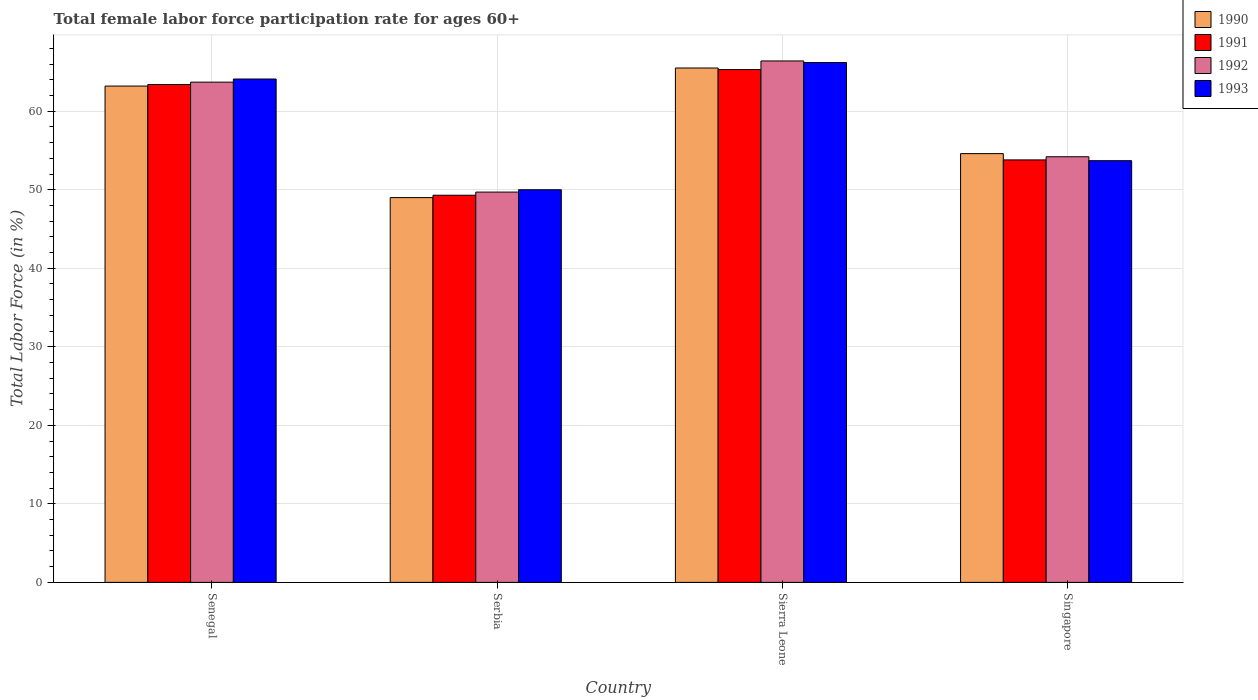How many different coloured bars are there?
Your response must be concise. 4. How many groups of bars are there?
Keep it short and to the point. 4. How many bars are there on the 4th tick from the left?
Ensure brevity in your answer.  4. How many bars are there on the 1st tick from the right?
Give a very brief answer. 4. What is the label of the 2nd group of bars from the left?
Keep it short and to the point. Serbia. What is the female labor force participation rate in 1993 in Singapore?
Offer a terse response. 53.7. Across all countries, what is the maximum female labor force participation rate in 1993?
Ensure brevity in your answer.  66.2. Across all countries, what is the minimum female labor force participation rate in 1992?
Make the answer very short. 49.7. In which country was the female labor force participation rate in 1992 maximum?
Provide a short and direct response. Sierra Leone. In which country was the female labor force participation rate in 1991 minimum?
Your answer should be very brief. Serbia. What is the total female labor force participation rate in 1993 in the graph?
Your answer should be very brief. 234. What is the difference between the female labor force participation rate in 1990 in Senegal and that in Singapore?
Offer a very short reply. 8.6. What is the difference between the female labor force participation rate in 1990 in Singapore and the female labor force participation rate in 1992 in Sierra Leone?
Offer a terse response. -11.8. What is the average female labor force participation rate in 1990 per country?
Keep it short and to the point. 58.07. What is the difference between the female labor force participation rate of/in 1992 and female labor force participation rate of/in 1993 in Serbia?
Offer a terse response. -0.3. In how many countries, is the female labor force participation rate in 1991 greater than 54 %?
Offer a terse response. 2. What is the ratio of the female labor force participation rate in 1991 in Senegal to that in Sierra Leone?
Ensure brevity in your answer.  0.97. Is the female labor force participation rate in 1992 in Senegal less than that in Sierra Leone?
Make the answer very short. Yes. Is the difference between the female labor force participation rate in 1992 in Senegal and Serbia greater than the difference between the female labor force participation rate in 1993 in Senegal and Serbia?
Give a very brief answer. No. What is the difference between the highest and the second highest female labor force participation rate in 1990?
Keep it short and to the point. 10.9. What is the difference between the highest and the lowest female labor force participation rate in 1993?
Provide a short and direct response. 16.2. In how many countries, is the female labor force participation rate in 1992 greater than the average female labor force participation rate in 1992 taken over all countries?
Give a very brief answer. 2. Is the sum of the female labor force participation rate in 1992 in Sierra Leone and Singapore greater than the maximum female labor force participation rate in 1993 across all countries?
Your response must be concise. Yes. Is it the case that in every country, the sum of the female labor force participation rate in 1992 and female labor force participation rate in 1993 is greater than the sum of female labor force participation rate in 1991 and female labor force participation rate in 1990?
Your answer should be very brief. No. What does the 1st bar from the left in Sierra Leone represents?
Provide a succinct answer. 1990. What does the 4th bar from the right in Sierra Leone represents?
Your response must be concise. 1990. How many bars are there?
Your answer should be compact. 16. Are all the bars in the graph horizontal?
Your answer should be very brief. No. How many countries are there in the graph?
Offer a terse response. 4. What is the difference between two consecutive major ticks on the Y-axis?
Keep it short and to the point. 10. Are the values on the major ticks of Y-axis written in scientific E-notation?
Your answer should be compact. No. Does the graph contain any zero values?
Your answer should be compact. No. Does the graph contain grids?
Ensure brevity in your answer.  Yes. How are the legend labels stacked?
Keep it short and to the point. Vertical. What is the title of the graph?
Your response must be concise. Total female labor force participation rate for ages 60+. What is the label or title of the Y-axis?
Ensure brevity in your answer.  Total Labor Force (in %). What is the Total Labor Force (in %) in 1990 in Senegal?
Your answer should be very brief. 63.2. What is the Total Labor Force (in %) in 1991 in Senegal?
Give a very brief answer. 63.4. What is the Total Labor Force (in %) in 1992 in Senegal?
Offer a very short reply. 63.7. What is the Total Labor Force (in %) in 1993 in Senegal?
Your response must be concise. 64.1. What is the Total Labor Force (in %) of 1991 in Serbia?
Keep it short and to the point. 49.3. What is the Total Labor Force (in %) of 1992 in Serbia?
Offer a terse response. 49.7. What is the Total Labor Force (in %) in 1990 in Sierra Leone?
Ensure brevity in your answer.  65.5. What is the Total Labor Force (in %) of 1991 in Sierra Leone?
Make the answer very short. 65.3. What is the Total Labor Force (in %) of 1992 in Sierra Leone?
Provide a short and direct response. 66.4. What is the Total Labor Force (in %) in 1993 in Sierra Leone?
Keep it short and to the point. 66.2. What is the Total Labor Force (in %) in 1990 in Singapore?
Provide a short and direct response. 54.6. What is the Total Labor Force (in %) in 1991 in Singapore?
Offer a terse response. 53.8. What is the Total Labor Force (in %) of 1992 in Singapore?
Give a very brief answer. 54.2. What is the Total Labor Force (in %) in 1993 in Singapore?
Give a very brief answer. 53.7. Across all countries, what is the maximum Total Labor Force (in %) of 1990?
Make the answer very short. 65.5. Across all countries, what is the maximum Total Labor Force (in %) in 1991?
Your answer should be compact. 65.3. Across all countries, what is the maximum Total Labor Force (in %) of 1992?
Offer a very short reply. 66.4. Across all countries, what is the maximum Total Labor Force (in %) of 1993?
Provide a succinct answer. 66.2. Across all countries, what is the minimum Total Labor Force (in %) of 1990?
Give a very brief answer. 49. Across all countries, what is the minimum Total Labor Force (in %) of 1991?
Your answer should be very brief. 49.3. Across all countries, what is the minimum Total Labor Force (in %) in 1992?
Offer a terse response. 49.7. What is the total Total Labor Force (in %) of 1990 in the graph?
Your answer should be compact. 232.3. What is the total Total Labor Force (in %) of 1991 in the graph?
Ensure brevity in your answer.  231.8. What is the total Total Labor Force (in %) in 1992 in the graph?
Your answer should be very brief. 234. What is the total Total Labor Force (in %) of 1993 in the graph?
Your response must be concise. 234. What is the difference between the Total Labor Force (in %) in 1991 in Senegal and that in Serbia?
Your answer should be very brief. 14.1. What is the difference between the Total Labor Force (in %) in 1992 in Senegal and that in Sierra Leone?
Offer a terse response. -2.7. What is the difference between the Total Labor Force (in %) in 1993 in Senegal and that in Sierra Leone?
Keep it short and to the point. -2.1. What is the difference between the Total Labor Force (in %) of 1990 in Senegal and that in Singapore?
Provide a short and direct response. 8.6. What is the difference between the Total Labor Force (in %) in 1991 in Senegal and that in Singapore?
Provide a succinct answer. 9.6. What is the difference between the Total Labor Force (in %) in 1990 in Serbia and that in Sierra Leone?
Offer a terse response. -16.5. What is the difference between the Total Labor Force (in %) in 1991 in Serbia and that in Sierra Leone?
Your answer should be compact. -16. What is the difference between the Total Labor Force (in %) in 1992 in Serbia and that in Sierra Leone?
Offer a terse response. -16.7. What is the difference between the Total Labor Force (in %) of 1993 in Serbia and that in Sierra Leone?
Keep it short and to the point. -16.2. What is the difference between the Total Labor Force (in %) of 1992 in Serbia and that in Singapore?
Your answer should be very brief. -4.5. What is the difference between the Total Labor Force (in %) in 1990 in Sierra Leone and that in Singapore?
Your response must be concise. 10.9. What is the difference between the Total Labor Force (in %) in 1992 in Sierra Leone and that in Singapore?
Give a very brief answer. 12.2. What is the difference between the Total Labor Force (in %) of 1993 in Sierra Leone and that in Singapore?
Make the answer very short. 12.5. What is the difference between the Total Labor Force (in %) in 1990 in Senegal and the Total Labor Force (in %) in 1991 in Serbia?
Ensure brevity in your answer.  13.9. What is the difference between the Total Labor Force (in %) of 1991 in Senegal and the Total Labor Force (in %) of 1993 in Serbia?
Make the answer very short. 13.4. What is the difference between the Total Labor Force (in %) in 1990 in Senegal and the Total Labor Force (in %) in 1993 in Sierra Leone?
Make the answer very short. -3. What is the difference between the Total Labor Force (in %) of 1991 in Senegal and the Total Labor Force (in %) of 1992 in Sierra Leone?
Provide a succinct answer. -3. What is the difference between the Total Labor Force (in %) in 1991 in Senegal and the Total Labor Force (in %) in 1993 in Sierra Leone?
Your answer should be compact. -2.8. What is the difference between the Total Labor Force (in %) in 1990 in Senegal and the Total Labor Force (in %) in 1991 in Singapore?
Your response must be concise. 9.4. What is the difference between the Total Labor Force (in %) in 1992 in Senegal and the Total Labor Force (in %) in 1993 in Singapore?
Your answer should be very brief. 10. What is the difference between the Total Labor Force (in %) in 1990 in Serbia and the Total Labor Force (in %) in 1991 in Sierra Leone?
Your answer should be compact. -16.3. What is the difference between the Total Labor Force (in %) of 1990 in Serbia and the Total Labor Force (in %) of 1992 in Sierra Leone?
Your response must be concise. -17.4. What is the difference between the Total Labor Force (in %) of 1990 in Serbia and the Total Labor Force (in %) of 1993 in Sierra Leone?
Ensure brevity in your answer.  -17.2. What is the difference between the Total Labor Force (in %) in 1991 in Serbia and the Total Labor Force (in %) in 1992 in Sierra Leone?
Your answer should be very brief. -17.1. What is the difference between the Total Labor Force (in %) in 1991 in Serbia and the Total Labor Force (in %) in 1993 in Sierra Leone?
Provide a short and direct response. -16.9. What is the difference between the Total Labor Force (in %) of 1992 in Serbia and the Total Labor Force (in %) of 1993 in Sierra Leone?
Your response must be concise. -16.5. What is the difference between the Total Labor Force (in %) of 1990 in Serbia and the Total Labor Force (in %) of 1993 in Singapore?
Offer a very short reply. -4.7. What is the difference between the Total Labor Force (in %) in 1991 in Serbia and the Total Labor Force (in %) in 1993 in Singapore?
Your answer should be compact. -4.4. What is the difference between the Total Labor Force (in %) in 1990 in Sierra Leone and the Total Labor Force (in %) in 1991 in Singapore?
Make the answer very short. 11.7. What is the difference between the Total Labor Force (in %) of 1990 in Sierra Leone and the Total Labor Force (in %) of 1992 in Singapore?
Your answer should be compact. 11.3. What is the difference between the Total Labor Force (in %) in 1991 in Sierra Leone and the Total Labor Force (in %) in 1992 in Singapore?
Keep it short and to the point. 11.1. What is the average Total Labor Force (in %) in 1990 per country?
Your response must be concise. 58.08. What is the average Total Labor Force (in %) of 1991 per country?
Keep it short and to the point. 57.95. What is the average Total Labor Force (in %) in 1992 per country?
Provide a succinct answer. 58.5. What is the average Total Labor Force (in %) in 1993 per country?
Your answer should be very brief. 58.5. What is the difference between the Total Labor Force (in %) of 1990 and Total Labor Force (in %) of 1993 in Senegal?
Give a very brief answer. -0.9. What is the difference between the Total Labor Force (in %) in 1991 and Total Labor Force (in %) in 1992 in Senegal?
Ensure brevity in your answer.  -0.3. What is the difference between the Total Labor Force (in %) of 1991 and Total Labor Force (in %) of 1993 in Senegal?
Offer a very short reply. -0.7. What is the difference between the Total Labor Force (in %) in 1992 and Total Labor Force (in %) in 1993 in Senegal?
Your answer should be very brief. -0.4. What is the difference between the Total Labor Force (in %) of 1990 and Total Labor Force (in %) of 1991 in Serbia?
Your answer should be compact. -0.3. What is the difference between the Total Labor Force (in %) of 1990 and Total Labor Force (in %) of 1992 in Serbia?
Your answer should be compact. -0.7. What is the difference between the Total Labor Force (in %) in 1990 and Total Labor Force (in %) in 1993 in Serbia?
Make the answer very short. -1. What is the difference between the Total Labor Force (in %) in 1991 and Total Labor Force (in %) in 1992 in Serbia?
Keep it short and to the point. -0.4. What is the difference between the Total Labor Force (in %) of 1991 and Total Labor Force (in %) of 1993 in Serbia?
Ensure brevity in your answer.  -0.7. What is the difference between the Total Labor Force (in %) of 1992 and Total Labor Force (in %) of 1993 in Serbia?
Keep it short and to the point. -0.3. What is the difference between the Total Labor Force (in %) in 1990 and Total Labor Force (in %) in 1993 in Sierra Leone?
Ensure brevity in your answer.  -0.7. What is the difference between the Total Labor Force (in %) in 1991 and Total Labor Force (in %) in 1992 in Sierra Leone?
Keep it short and to the point. -1.1. What is the difference between the Total Labor Force (in %) in 1991 and Total Labor Force (in %) in 1993 in Sierra Leone?
Provide a succinct answer. -0.9. What is the difference between the Total Labor Force (in %) in 1991 and Total Labor Force (in %) in 1992 in Singapore?
Ensure brevity in your answer.  -0.4. What is the difference between the Total Labor Force (in %) of 1992 and Total Labor Force (in %) of 1993 in Singapore?
Ensure brevity in your answer.  0.5. What is the ratio of the Total Labor Force (in %) of 1990 in Senegal to that in Serbia?
Offer a terse response. 1.29. What is the ratio of the Total Labor Force (in %) in 1991 in Senegal to that in Serbia?
Offer a very short reply. 1.29. What is the ratio of the Total Labor Force (in %) in 1992 in Senegal to that in Serbia?
Your answer should be compact. 1.28. What is the ratio of the Total Labor Force (in %) of 1993 in Senegal to that in Serbia?
Ensure brevity in your answer.  1.28. What is the ratio of the Total Labor Force (in %) of 1990 in Senegal to that in Sierra Leone?
Provide a short and direct response. 0.96. What is the ratio of the Total Labor Force (in %) of 1991 in Senegal to that in Sierra Leone?
Provide a succinct answer. 0.97. What is the ratio of the Total Labor Force (in %) in 1992 in Senegal to that in Sierra Leone?
Provide a succinct answer. 0.96. What is the ratio of the Total Labor Force (in %) in 1993 in Senegal to that in Sierra Leone?
Your answer should be compact. 0.97. What is the ratio of the Total Labor Force (in %) of 1990 in Senegal to that in Singapore?
Your answer should be compact. 1.16. What is the ratio of the Total Labor Force (in %) of 1991 in Senegal to that in Singapore?
Make the answer very short. 1.18. What is the ratio of the Total Labor Force (in %) of 1992 in Senegal to that in Singapore?
Your answer should be compact. 1.18. What is the ratio of the Total Labor Force (in %) of 1993 in Senegal to that in Singapore?
Your answer should be very brief. 1.19. What is the ratio of the Total Labor Force (in %) of 1990 in Serbia to that in Sierra Leone?
Provide a succinct answer. 0.75. What is the ratio of the Total Labor Force (in %) of 1991 in Serbia to that in Sierra Leone?
Your response must be concise. 0.76. What is the ratio of the Total Labor Force (in %) in 1992 in Serbia to that in Sierra Leone?
Provide a succinct answer. 0.75. What is the ratio of the Total Labor Force (in %) in 1993 in Serbia to that in Sierra Leone?
Provide a succinct answer. 0.76. What is the ratio of the Total Labor Force (in %) of 1990 in Serbia to that in Singapore?
Provide a succinct answer. 0.9. What is the ratio of the Total Labor Force (in %) in 1991 in Serbia to that in Singapore?
Provide a short and direct response. 0.92. What is the ratio of the Total Labor Force (in %) of 1992 in Serbia to that in Singapore?
Your answer should be very brief. 0.92. What is the ratio of the Total Labor Force (in %) in 1993 in Serbia to that in Singapore?
Your answer should be very brief. 0.93. What is the ratio of the Total Labor Force (in %) of 1990 in Sierra Leone to that in Singapore?
Give a very brief answer. 1.2. What is the ratio of the Total Labor Force (in %) in 1991 in Sierra Leone to that in Singapore?
Provide a short and direct response. 1.21. What is the ratio of the Total Labor Force (in %) of 1992 in Sierra Leone to that in Singapore?
Make the answer very short. 1.23. What is the ratio of the Total Labor Force (in %) in 1993 in Sierra Leone to that in Singapore?
Your response must be concise. 1.23. What is the difference between the highest and the second highest Total Labor Force (in %) of 1993?
Your answer should be compact. 2.1. What is the difference between the highest and the lowest Total Labor Force (in %) in 1990?
Offer a very short reply. 16.5. 